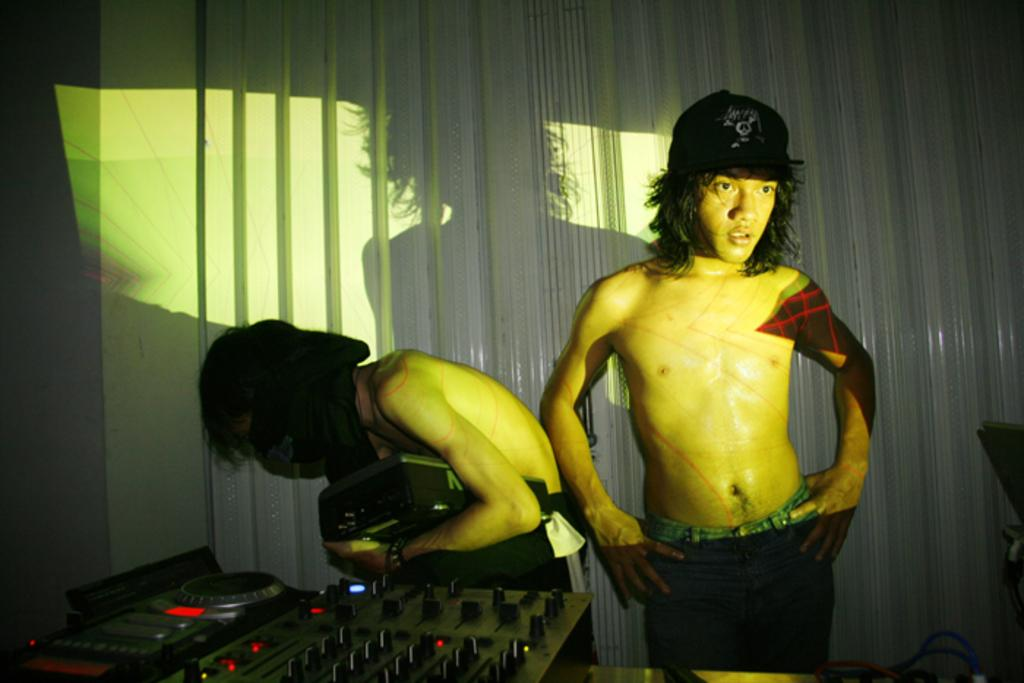How many people are present in the image? There are two people standing in the image. What else can be seen in the image besides the people? There is a musical instrument in the image. What type of verse can be seen on the musical instrument in the image? There is no verse present on the musical instrument in the image. 